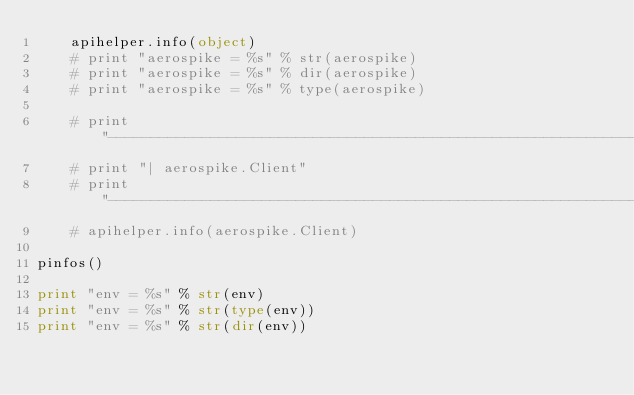Convert code to text. <code><loc_0><loc_0><loc_500><loc_500><_Python_>    apihelper.info(object)
    # print "aerospike = %s" % str(aerospike)
    # print "aerospike = %s" % dir(aerospike)
    # print "aerospike = %s" % type(aerospike)

    # print "--------------------------------------------------------------------------------"
    # print "| aerospike.Client"
    # print "--------------------------------------------------------------------------------"
    # apihelper.info(aerospike.Client)

pinfos()

print "env = %s" % str(env)
print "env = %s" % str(type(env))
print "env = %s" % str(dir(env))
</code> 